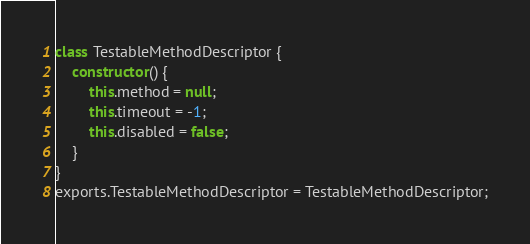Convert code to text. <code><loc_0><loc_0><loc_500><loc_500><_JavaScript_>class TestableMethodDescriptor {
    constructor() {
        this.method = null;
        this.timeout = -1;
        this.disabled = false;
    }
}
exports.TestableMethodDescriptor = TestableMethodDescriptor;
</code> 